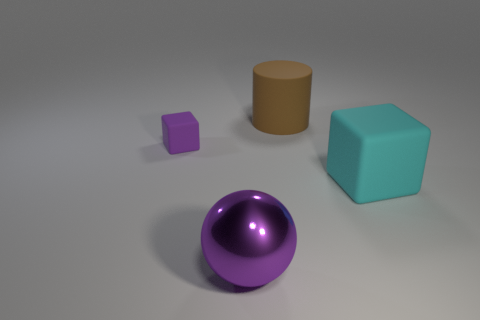Subtract all blue cylinders. Subtract all red blocks. How many cylinders are left? 1 Add 3 big brown things. How many objects exist? 7 Subtract all balls. How many objects are left? 3 Add 3 large shiny balls. How many large shiny balls exist? 4 Subtract 0 gray cubes. How many objects are left? 4 Subtract all brown cylinders. Subtract all large cyan rubber blocks. How many objects are left? 2 Add 1 purple rubber things. How many purple rubber things are left? 2 